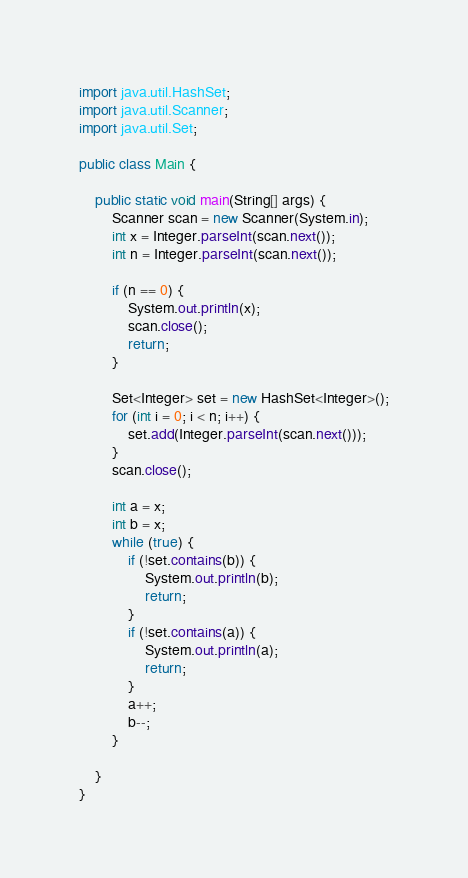<code> <loc_0><loc_0><loc_500><loc_500><_Java_>
import java.util.HashSet;
import java.util.Scanner;
import java.util.Set;

public class Main {

    public static void main(String[] args) {
        Scanner scan = new Scanner(System.in);
        int x = Integer.parseInt(scan.next());
        int n = Integer.parseInt(scan.next());

        if (n == 0) {
            System.out.println(x);
            scan.close();
            return;
        }

        Set<Integer> set = new HashSet<Integer>();
        for (int i = 0; i < n; i++) {
            set.add(Integer.parseInt(scan.next()));
        }
        scan.close();

        int a = x;
        int b = x;
        while (true) {
            if (!set.contains(b)) {
                System.out.println(b);
                return;
            }
            if (!set.contains(a)) {
                System.out.println(a);
                return;
            }
            a++;
            b--;
        }

    }
}
</code> 